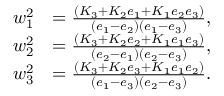<formula> <loc_0><loc_0><loc_500><loc_500>\begin{array} { r l } { w _ { 1 } ^ { 2 } } & { = \frac { ( K _ { 3 } + K _ { 2 } e _ { 1 } + K _ { 1 } e _ { 2 } e _ { 3 } ) } { ( e _ { 1 } - e _ { 2 } ) ( e _ { 1 } - e _ { 3 } ) } , } \\ { w _ { 2 } ^ { 2 } } & { = \frac { ( K _ { 3 } + K _ { 2 } e _ { 2 } + K _ { 1 } e _ { 1 } e _ { 3 } ) } { ( e _ { 2 } - e _ { 1 } ) ( e _ { 2 } - e _ { 3 } ) } , } \\ { w _ { 3 } ^ { 2 } } & { = \frac { ( K _ { 3 } + K _ { 2 } e _ { 3 } + K _ { 1 } e _ { 1 } e _ { 2 } ) } { ( e _ { 1 } - e _ { 3 } ) ( e _ { 2 } - e _ { 3 } ) } . } \end{array}</formula> 